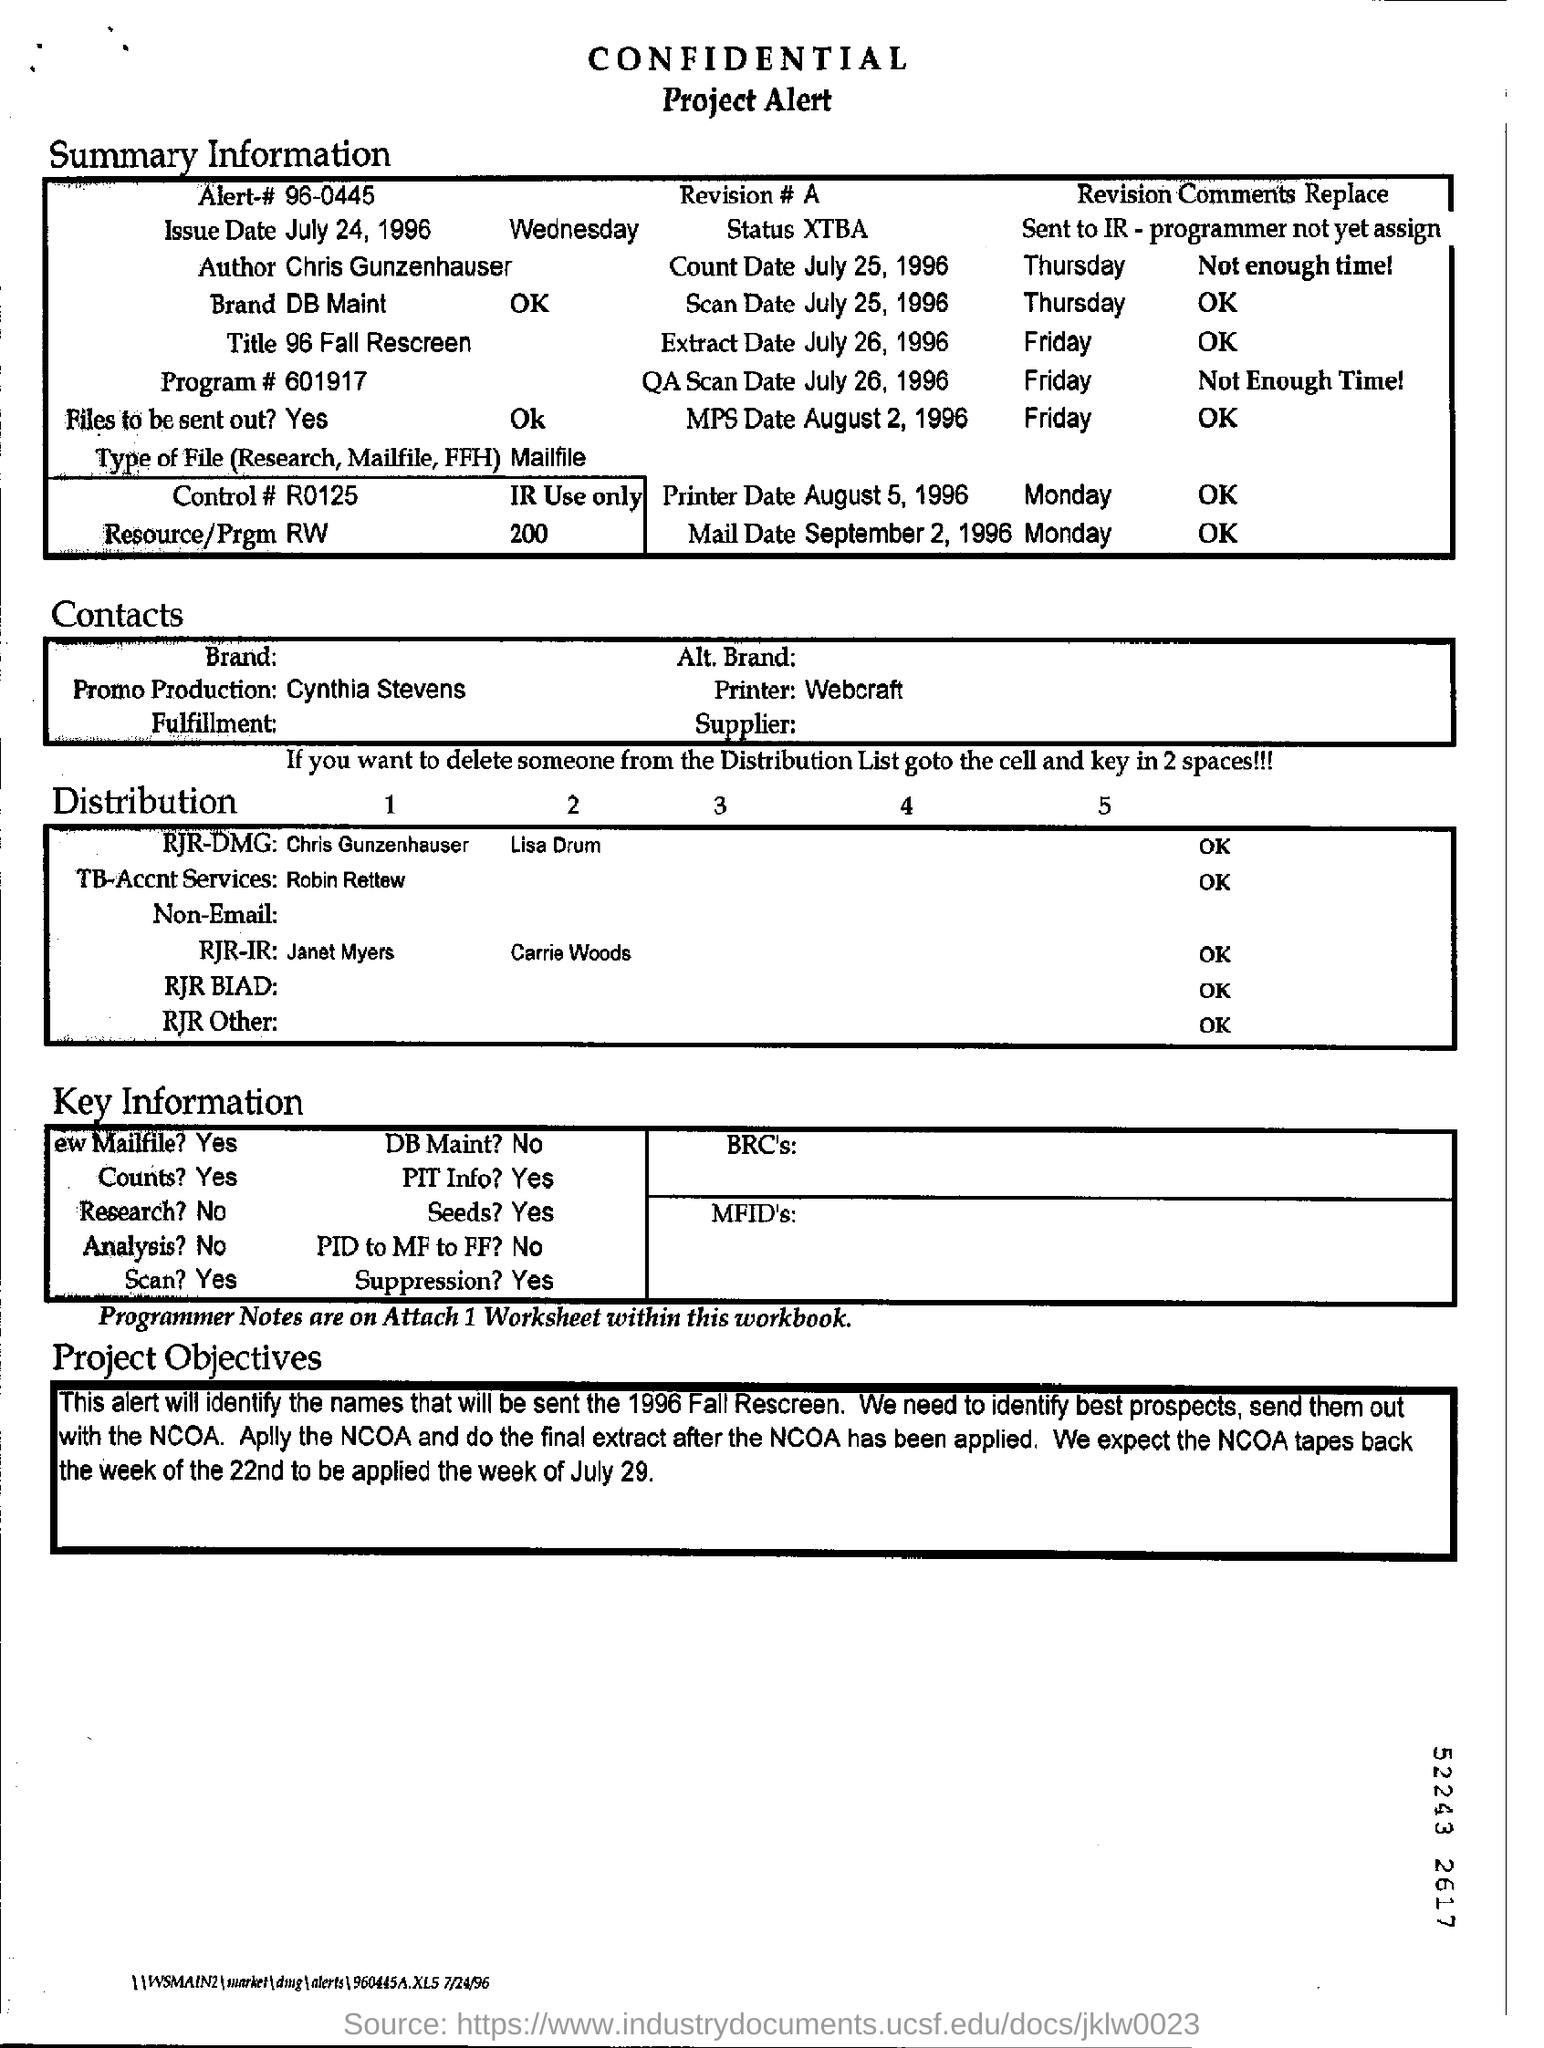What is the issue date of the project?
Give a very brief answer. July 24, 1996. Who is the author of the project?
Your answer should be very brief. Chris Gunzenhauser. 